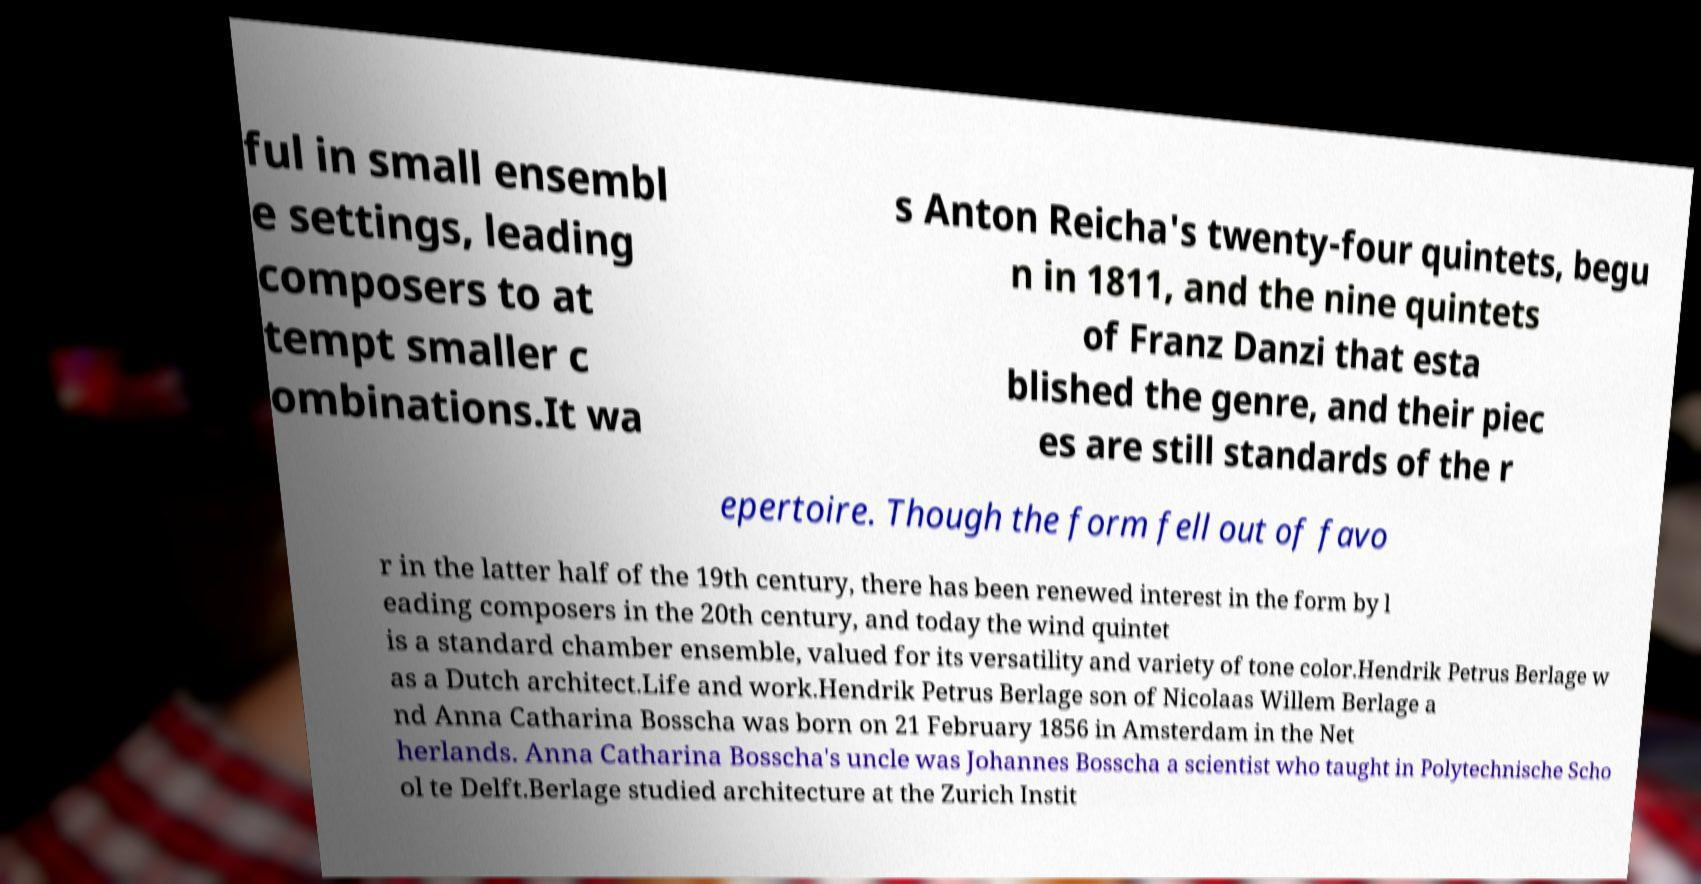What messages or text are displayed in this image? I need them in a readable, typed format. ful in small ensembl e settings, leading composers to at tempt smaller c ombinations.It wa s Anton Reicha's twenty-four quintets, begu n in 1811, and the nine quintets of Franz Danzi that esta blished the genre, and their piec es are still standards of the r epertoire. Though the form fell out of favo r in the latter half of the 19th century, there has been renewed interest in the form by l eading composers in the 20th century, and today the wind quintet is a standard chamber ensemble, valued for its versatility and variety of tone color.Hendrik Petrus Berlage w as a Dutch architect.Life and work.Hendrik Petrus Berlage son of Nicolaas Willem Berlage a nd Anna Catharina Bosscha was born on 21 February 1856 in Amsterdam in the Net herlands. Anna Catharina Bosscha's uncle was Johannes Bosscha a scientist who taught in Polytechnische Scho ol te Delft.Berlage studied architecture at the Zurich Instit 